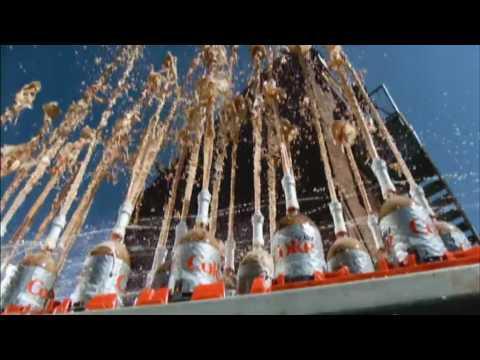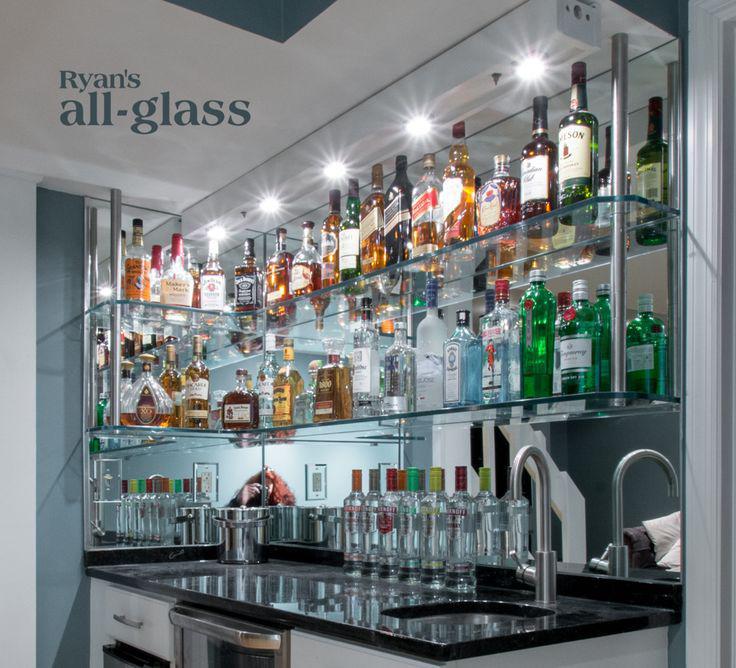The first image is the image on the left, the second image is the image on the right. Considering the images on both sides, is "The right image shows label-less glass bottles of various colors strung on rows of vertical bars, with some rightside-up and some upside-down." valid? Answer yes or no. No. The first image is the image on the left, the second image is the image on the right. For the images shown, is this caption "Some bottles have liquor in them." true? Answer yes or no. Yes. 